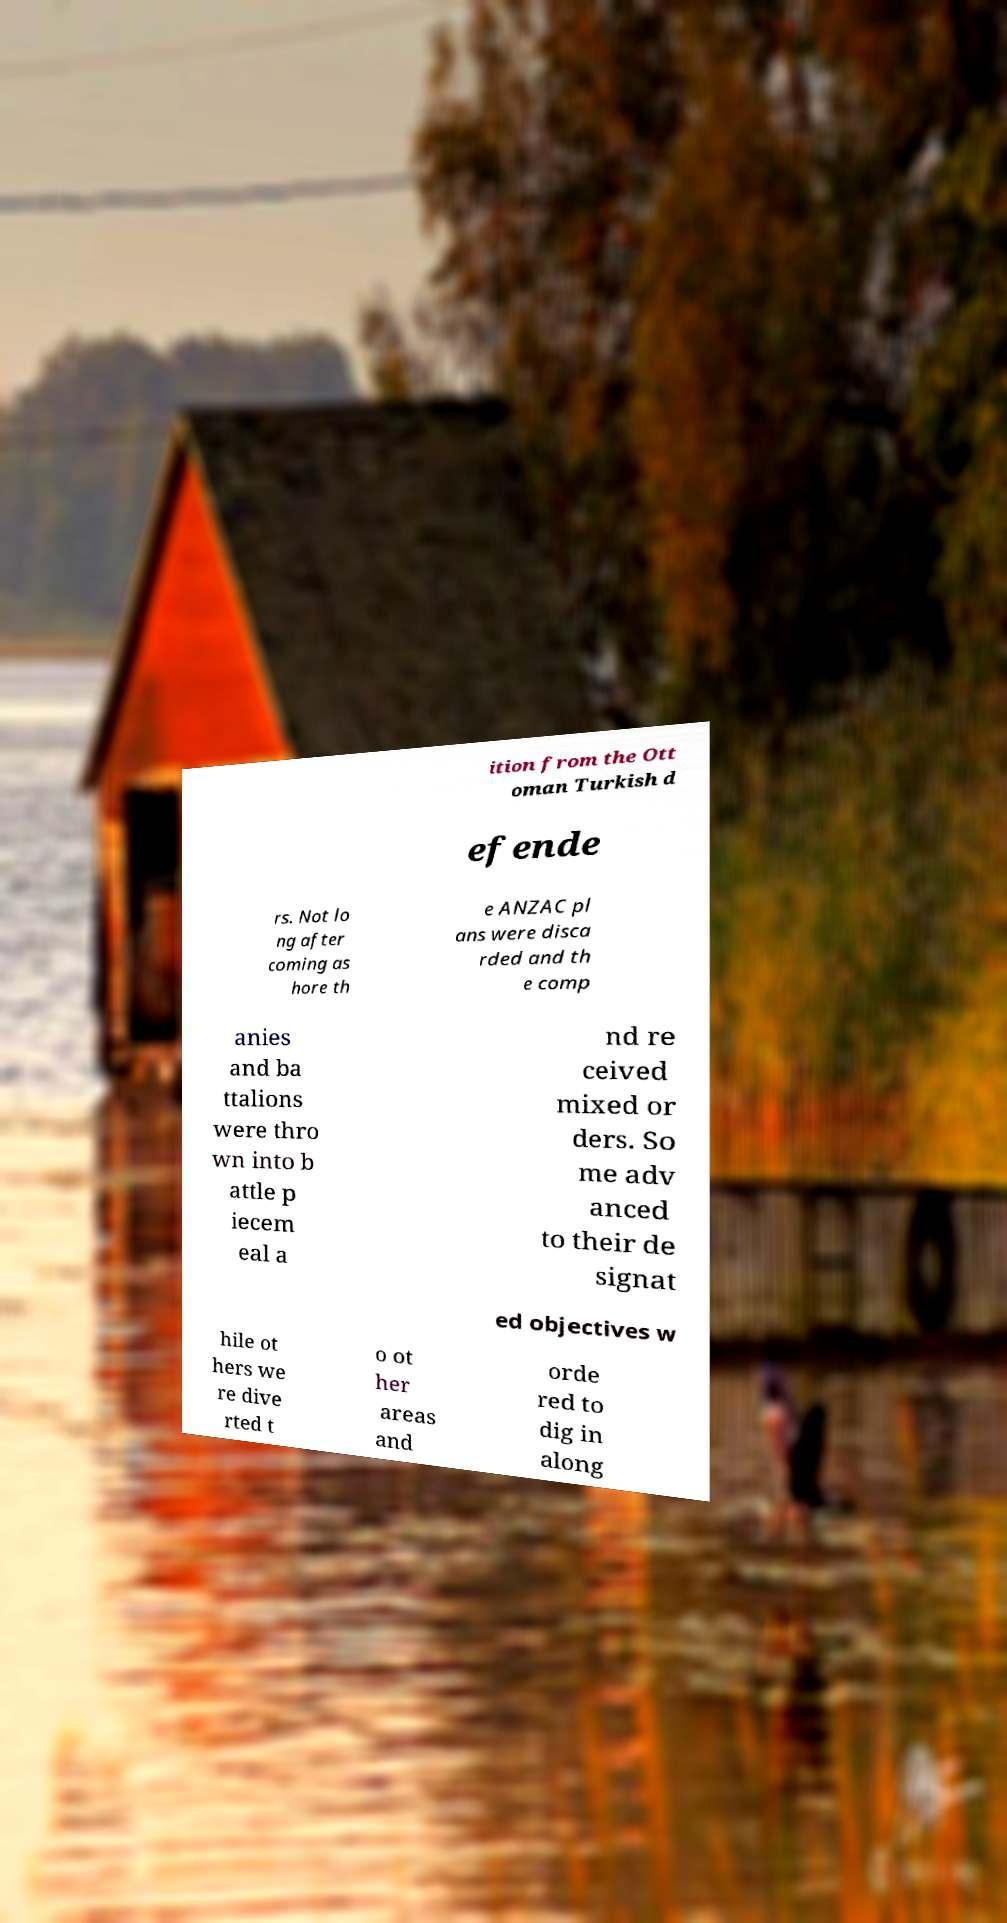Can you accurately transcribe the text from the provided image for me? ition from the Ott oman Turkish d efende rs. Not lo ng after coming as hore th e ANZAC pl ans were disca rded and th e comp anies and ba ttalions were thro wn into b attle p iecem eal a nd re ceived mixed or ders. So me adv anced to their de signat ed objectives w hile ot hers we re dive rted t o ot her areas and orde red to dig in along 